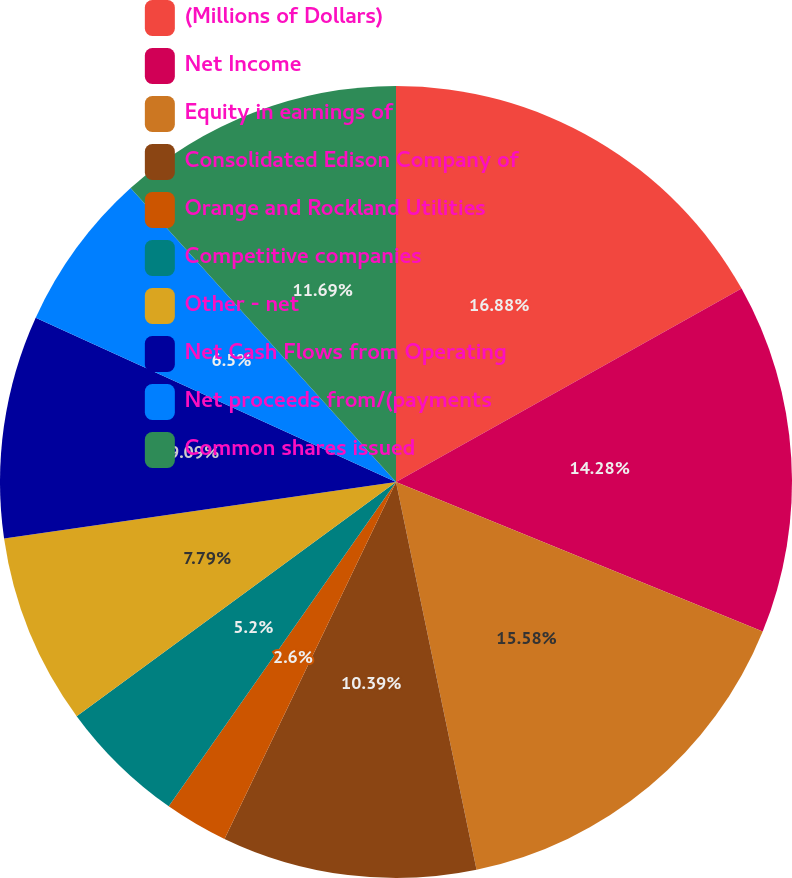<chart> <loc_0><loc_0><loc_500><loc_500><pie_chart><fcel>(Millions of Dollars)<fcel>Net Income<fcel>Equity in earnings of<fcel>Consolidated Edison Company of<fcel>Orange and Rockland Utilities<fcel>Competitive companies<fcel>Other - net<fcel>Net Cash Flows from Operating<fcel>Net proceeds from/(payments<fcel>Common shares issued<nl><fcel>16.88%<fcel>14.28%<fcel>15.58%<fcel>10.39%<fcel>2.6%<fcel>5.2%<fcel>7.79%<fcel>9.09%<fcel>6.5%<fcel>11.69%<nl></chart> 